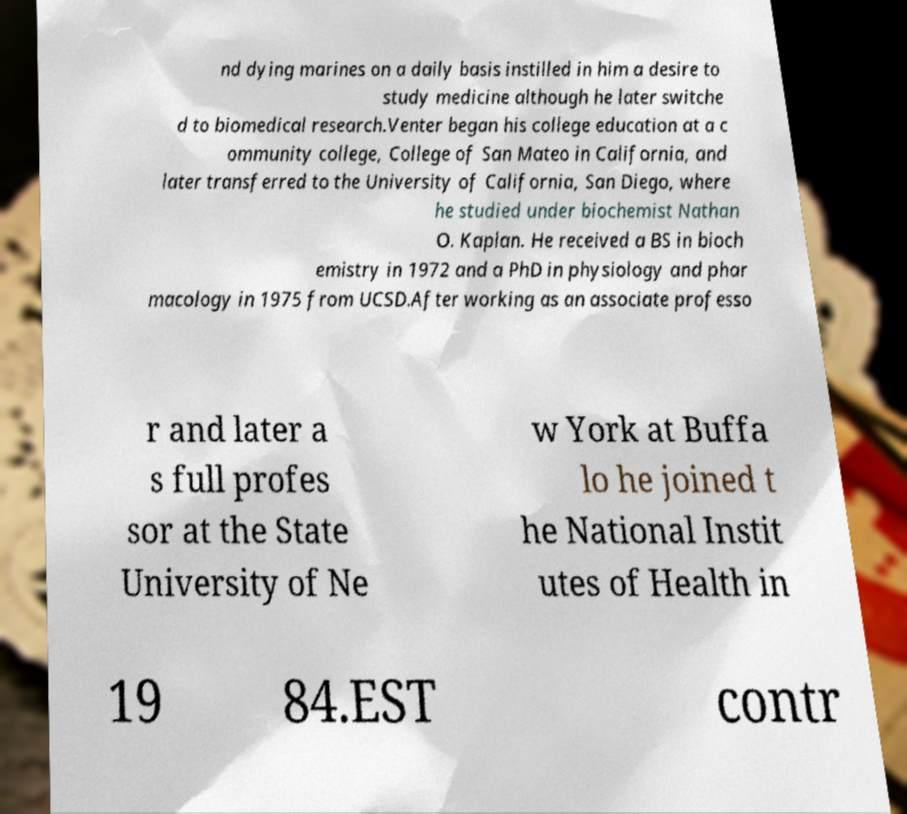Can you accurately transcribe the text from the provided image for me? nd dying marines on a daily basis instilled in him a desire to study medicine although he later switche d to biomedical research.Venter began his college education at a c ommunity college, College of San Mateo in California, and later transferred to the University of California, San Diego, where he studied under biochemist Nathan O. Kaplan. He received a BS in bioch emistry in 1972 and a PhD in physiology and phar macology in 1975 from UCSD.After working as an associate professo r and later a s full profes sor at the State University of Ne w York at Buffa lo he joined t he National Instit utes of Health in 19 84.EST contr 